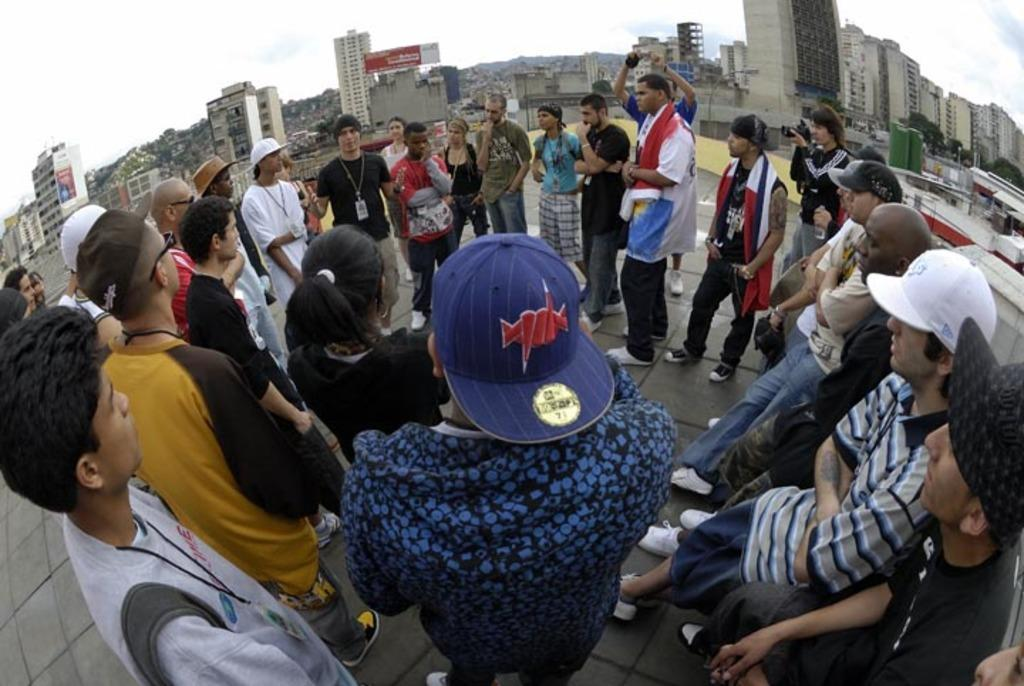What are the people in the image doing? There are people standing in the image. What are two of the people holding? Two persons are holding cameras. What can be seen in the background of the image? There are buildings and trees in the background of the image. What is visible at the top of the image? The sky is visible at the top of the image. What type of reaction can be seen from the boat in the image? There is no boat present in the image, so it is not possible to determine any reaction from a boat. 